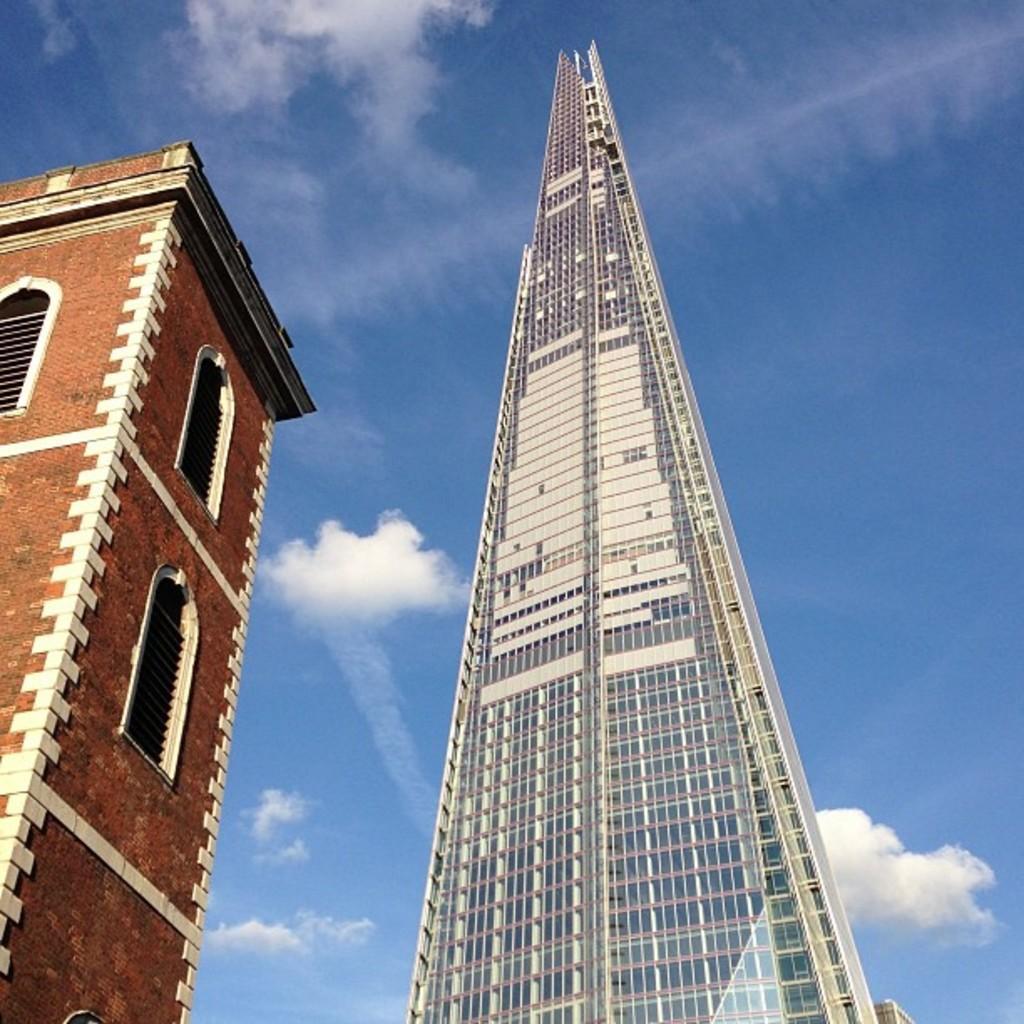Could you give a brief overview of what you see in this image? In the picture I can see two tower buildings. In the background I can see the sky. 